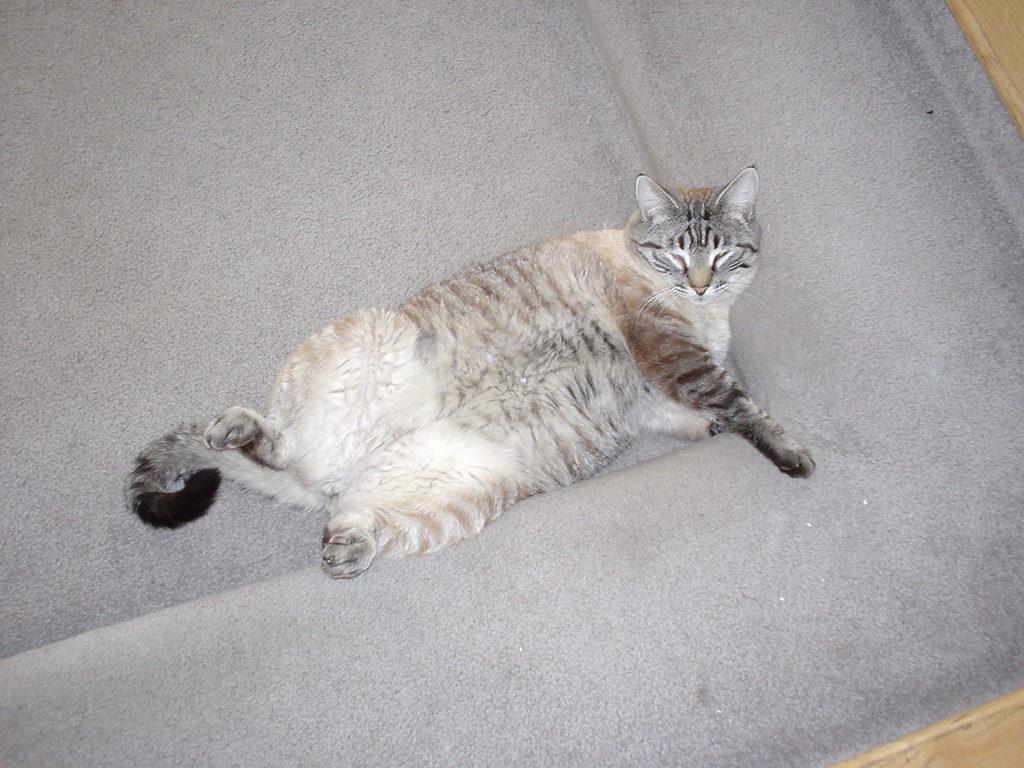Could you give a brief overview of what you see in this image? We can see a cat on this carpet. 